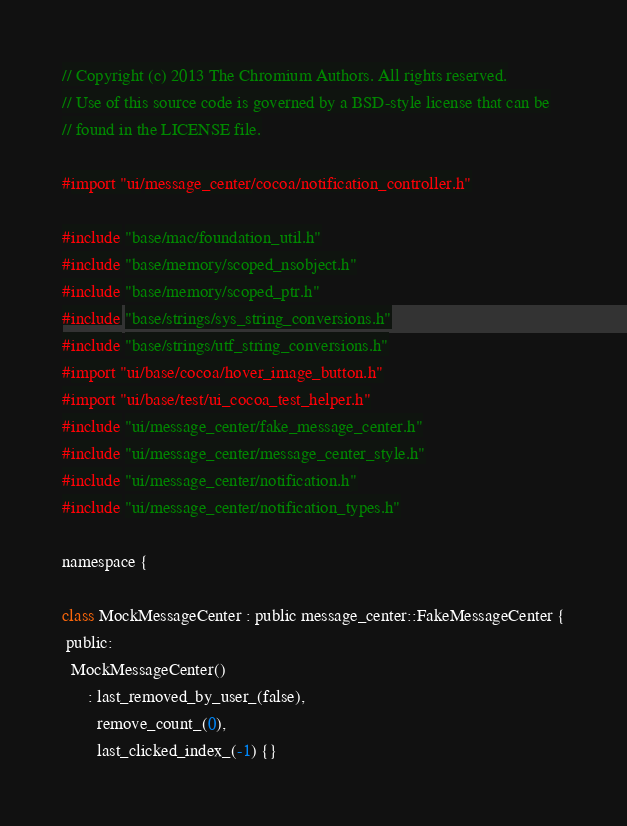<code> <loc_0><loc_0><loc_500><loc_500><_ObjectiveC_>// Copyright (c) 2013 The Chromium Authors. All rights reserved.
// Use of this source code is governed by a BSD-style license that can be
// found in the LICENSE file.

#import "ui/message_center/cocoa/notification_controller.h"

#include "base/mac/foundation_util.h"
#include "base/memory/scoped_nsobject.h"
#include "base/memory/scoped_ptr.h"
#include "base/strings/sys_string_conversions.h"
#include "base/strings/utf_string_conversions.h"
#import "ui/base/cocoa/hover_image_button.h"
#import "ui/base/test/ui_cocoa_test_helper.h"
#include "ui/message_center/fake_message_center.h"
#include "ui/message_center/message_center_style.h"
#include "ui/message_center/notification.h"
#include "ui/message_center/notification_types.h"

namespace {

class MockMessageCenter : public message_center::FakeMessageCenter {
 public:
  MockMessageCenter()
      : last_removed_by_user_(false),
        remove_count_(0),
        last_clicked_index_(-1) {}
</code> 